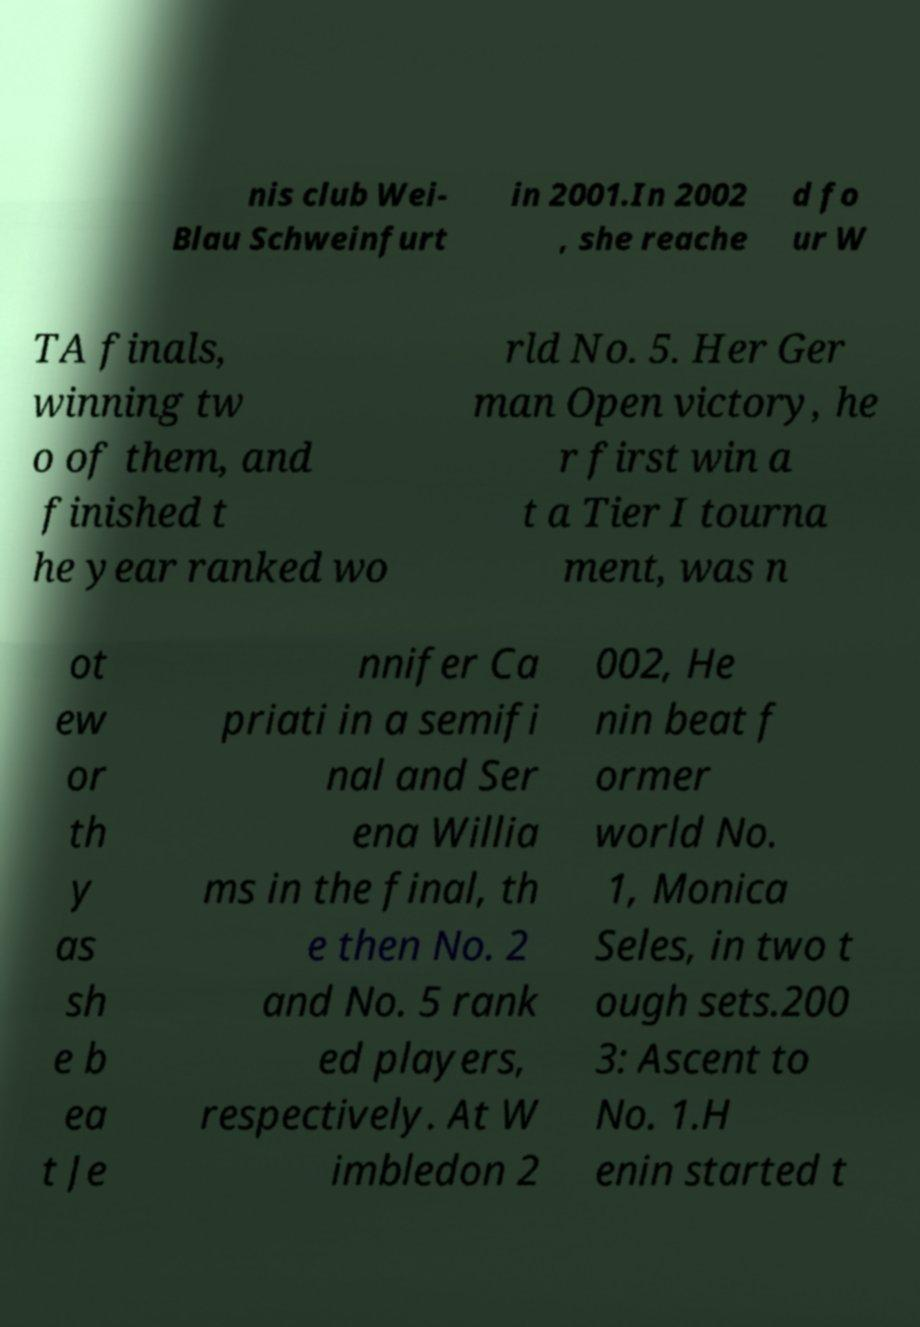For documentation purposes, I need the text within this image transcribed. Could you provide that? nis club Wei- Blau Schweinfurt in 2001.In 2002 , she reache d fo ur W TA finals, winning tw o of them, and finished t he year ranked wo rld No. 5. Her Ger man Open victory, he r first win a t a Tier I tourna ment, was n ot ew or th y as sh e b ea t Je nnifer Ca priati in a semifi nal and Ser ena Willia ms in the final, th e then No. 2 and No. 5 rank ed players, respectively. At W imbledon 2 002, He nin beat f ormer world No. 1, Monica Seles, in two t ough sets.200 3: Ascent to No. 1.H enin started t 